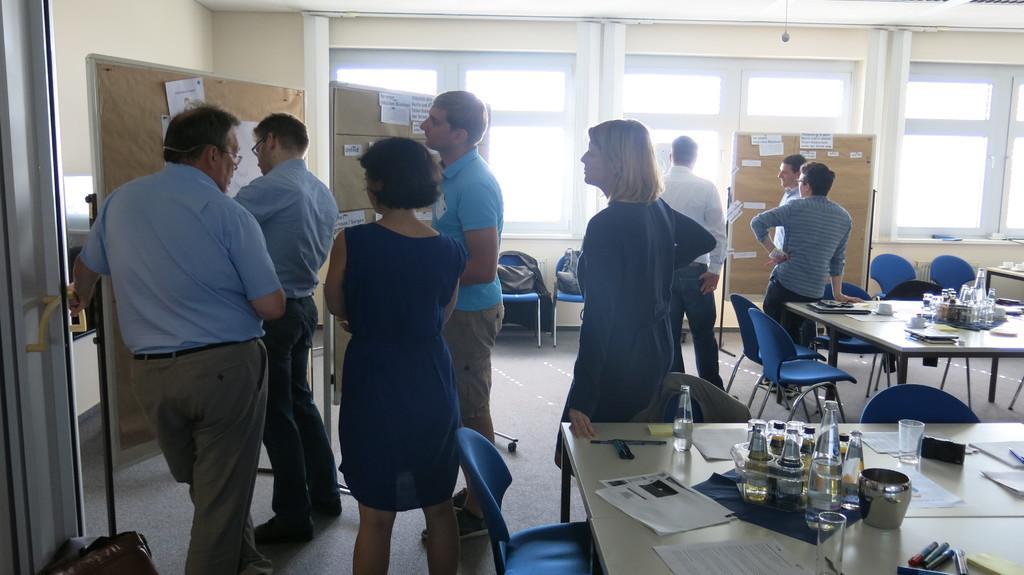Can you describe this image briefly? in this picture there are people in the image and there are tables and chairs in the image, tables contains papers, bottles and other items, there are windows in the background area of the image and there are posters on the boards in the image. 